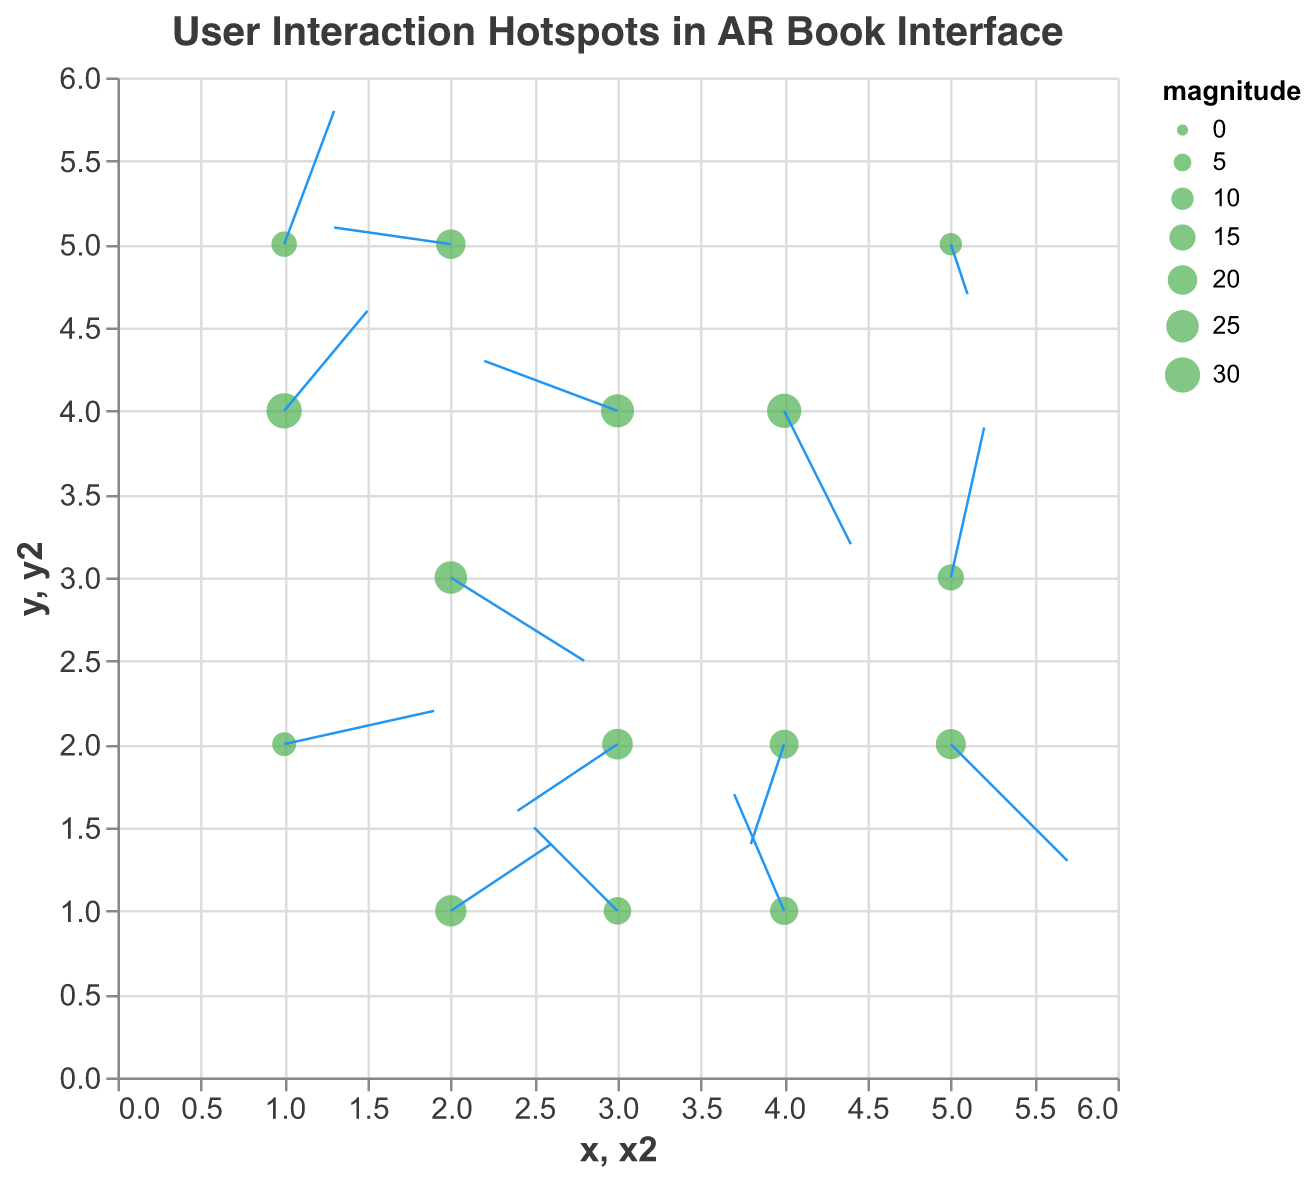What is the title of the plot? The plot title is displayed at the top and reads: "User Interaction Hotspots in AR Book Interface".
Answer: User Interaction Hotspots in AR Book Interface What are the x and y axis ranges? The x and y axes both have ranges from 0 to 6 as indicated by their scales on the plot.
Answer: 0 to 6 How many interaction points are depicted in the plot? Counting the number of different (x, y) coordinates corresponding to interaction points in the plot, we identify 15 points.
Answer: 15 Which point has the highest interaction frequency? The magnitude of interaction frequency for each point is visualized by its size. The largest point corresponds to (1,4) with a magnitude of 30.
Answer: (1, 4) Which direction does the interaction at (4,4) point towards? By examining the arrow (direction vector) originating from the point (4,4), it points towards coordinates (4.4, 3.2), indicating a direction with components u=0.4 and v=-0.8.
Answer: (4.4, 3.2) Compare the interaction frequencies at (3,2) and (2,3). Which one is higher? For point (3,2) the magnitude is 22, while for point (2,3) the magnitude is 25. Thus, the interaction frequency at (2,3) is higher.
Answer: (2,3) What is the average magnitude of interaction frequencies? Adding up all magnitudes: 25 + 18 + 30 + 22 + 15 + 20 + 28 + 12 + 17 + 10 + 23 + 19 + 14 + 26 + 21 = 300. There are 15 interaction points. The average is 300/15.
Answer: 20 Which interaction point has the smallest magnitude and what is it? By examining the size of interaction points we determine that the smallest point has a magnitude of 10, which occurs at (5,5).
Answer: (5,5), 10 What is the direction vector for the interaction at point (1,5)? The vector components from the point (1,5) are u=0.3 and v=0.8 resulting in a direction towards (1.3, 5.8).
Answer: (1.3, 5.8) Which interaction point has a negative flow in both u and v directions? By looking at points where both u and v are negative, we find that point (3,2) has values u=-0.6 and v=-0.4 directing the flow towards (2.4, 1.6).
Answer: (3,2) 